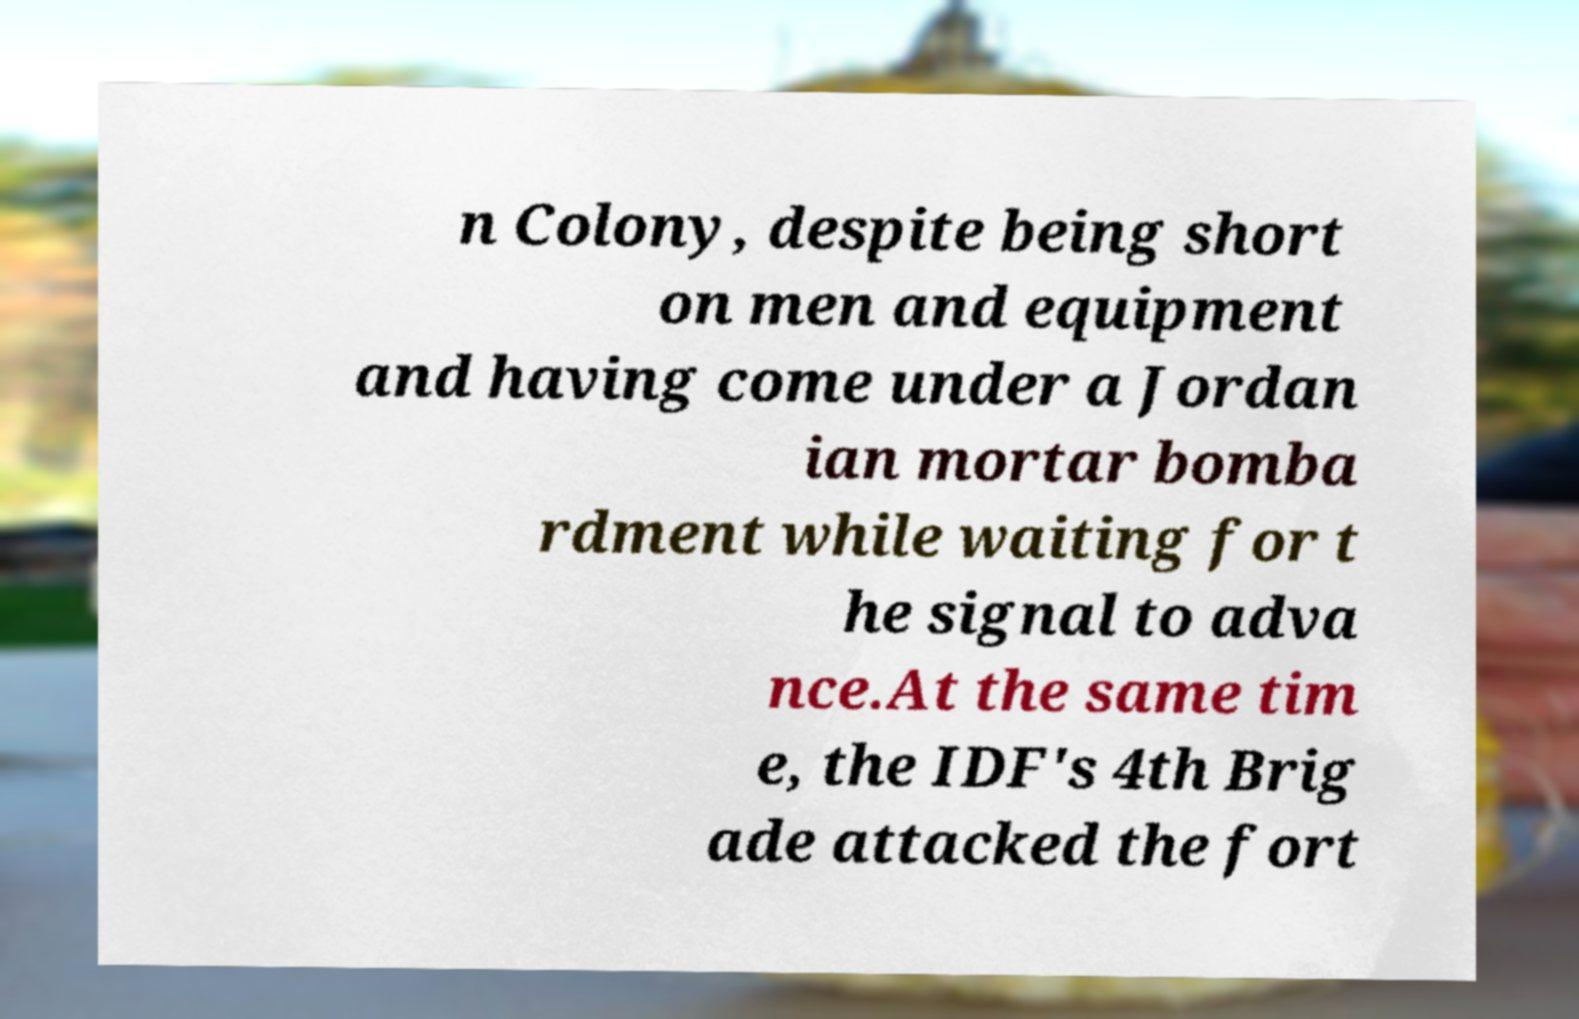Can you read and provide the text displayed in the image?This photo seems to have some interesting text. Can you extract and type it out for me? n Colony, despite being short on men and equipment and having come under a Jordan ian mortar bomba rdment while waiting for t he signal to adva nce.At the same tim e, the IDF's 4th Brig ade attacked the fort 